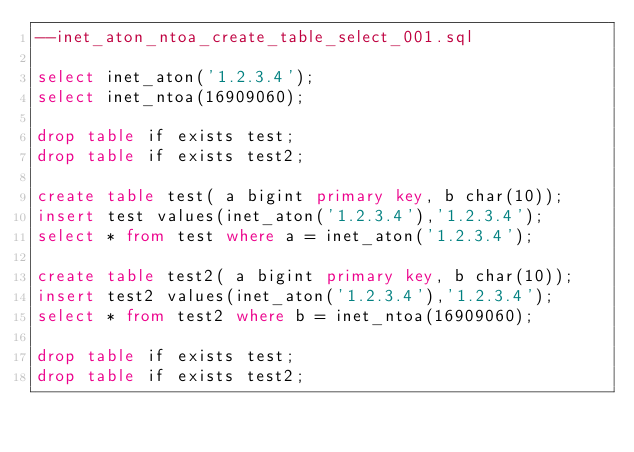<code> <loc_0><loc_0><loc_500><loc_500><_SQL_>--inet_aton_ntoa_create_table_select_001.sql

select inet_aton('1.2.3.4');
select inet_ntoa(16909060);

drop table if exists test;
drop table if exists test2;

create table test( a bigint primary key, b char(10));
insert test values(inet_aton('1.2.3.4'),'1.2.3.4');
select * from test where a = inet_aton('1.2.3.4');

create table test2( a bigint primary key, b char(10));
insert test2 values(inet_aton('1.2.3.4'),'1.2.3.4');
select * from test2 where b = inet_ntoa(16909060);

drop table if exists test;
drop table if exists test2;</code> 